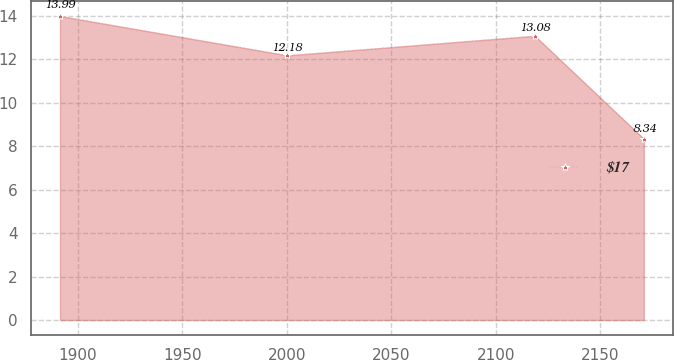Convert chart. <chart><loc_0><loc_0><loc_500><loc_500><line_chart><ecel><fcel>$17<nl><fcel>1891.55<fcel>13.99<nl><fcel>2000.32<fcel>12.18<nl><fcel>2118.72<fcel>13.08<nl><fcel>2170.87<fcel>8.34<nl></chart> 